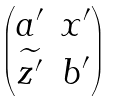Convert formula to latex. <formula><loc_0><loc_0><loc_500><loc_500>\begin{pmatrix} a ^ { \prime } & x ^ { \prime } \\ \widetilde { z ^ { \prime } } & b ^ { \prime } \end{pmatrix}</formula> 